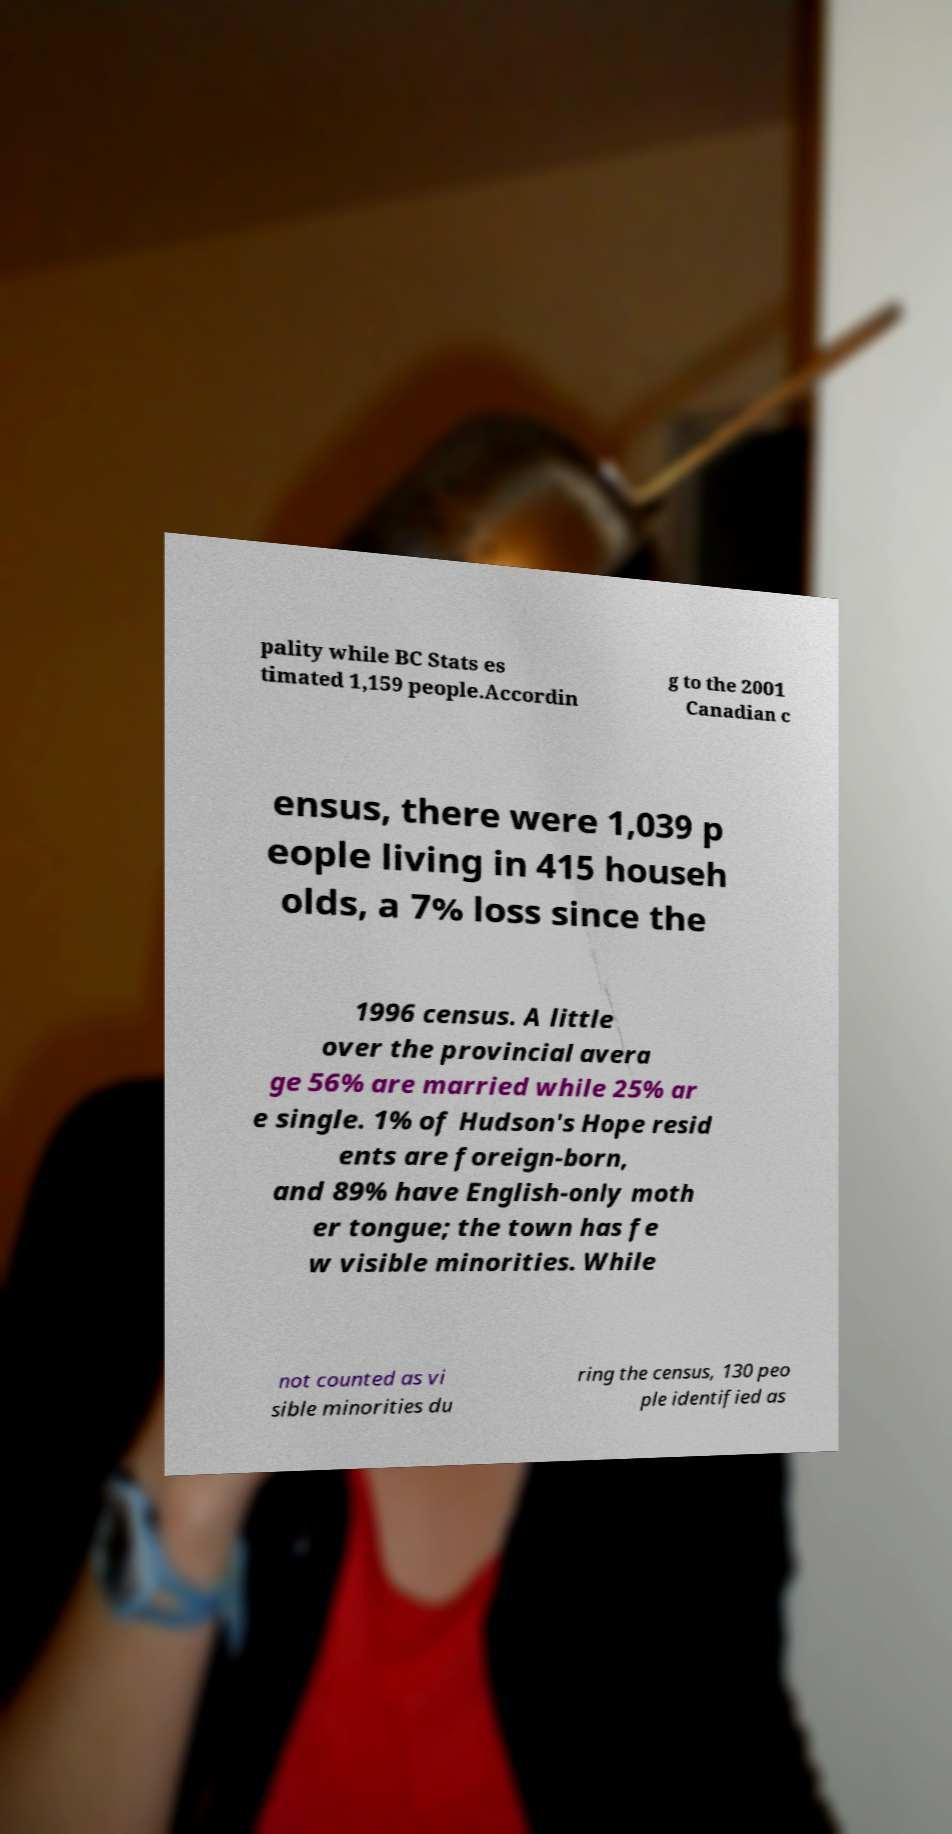Please identify and transcribe the text found in this image. pality while BC Stats es timated 1,159 people.Accordin g to the 2001 Canadian c ensus, there were 1,039 p eople living in 415 househ olds, a 7% loss since the 1996 census. A little over the provincial avera ge 56% are married while 25% ar e single. 1% of Hudson's Hope resid ents are foreign-born, and 89% have English-only moth er tongue; the town has fe w visible minorities. While not counted as vi sible minorities du ring the census, 130 peo ple identified as 